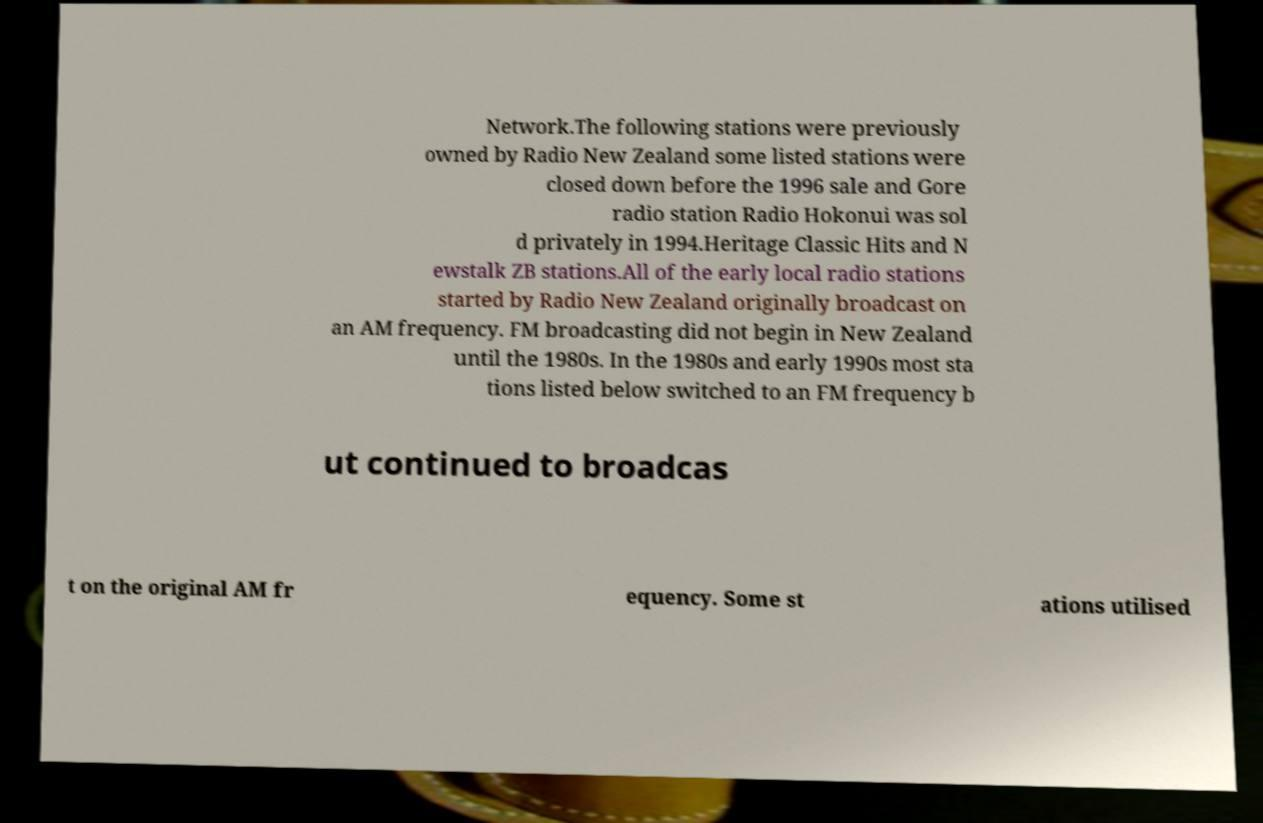Could you extract and type out the text from this image? Network.The following stations were previously owned by Radio New Zealand some listed stations were closed down before the 1996 sale and Gore radio station Radio Hokonui was sol d privately in 1994.Heritage Classic Hits and N ewstalk ZB stations.All of the early local radio stations started by Radio New Zealand originally broadcast on an AM frequency. FM broadcasting did not begin in New Zealand until the 1980s. In the 1980s and early 1990s most sta tions listed below switched to an FM frequency b ut continued to broadcas t on the original AM fr equency. Some st ations utilised 